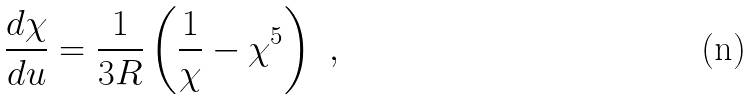Convert formula to latex. <formula><loc_0><loc_0><loc_500><loc_500>\frac { d \chi } { d u } = \frac { 1 } { 3 R } \left ( \frac { 1 } { \chi } - \chi ^ { 5 } \right ) \ ,</formula> 